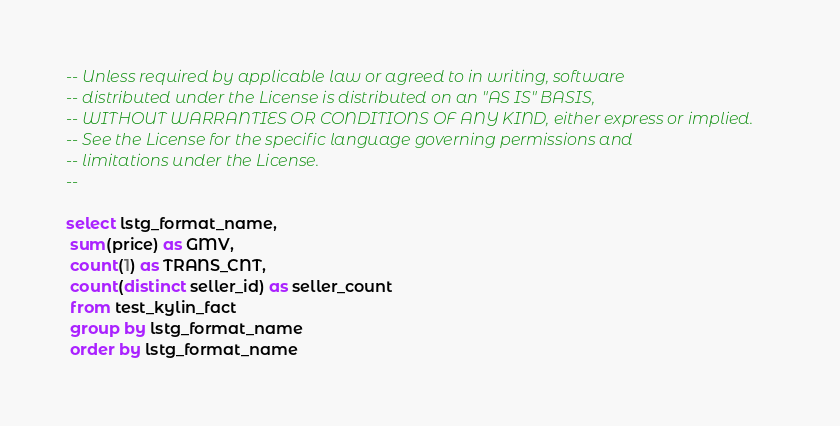<code> <loc_0><loc_0><loc_500><loc_500><_SQL_>-- Unless required by applicable law or agreed to in writing, software
-- distributed under the License is distributed on an "AS IS" BASIS,
-- WITHOUT WARRANTIES OR CONDITIONS OF ANY KIND, either express or implied.
-- See the License for the specific language governing permissions and
-- limitations under the License.
--

select lstg_format_name,
 sum(price) as GMV,
 count(1) as TRANS_CNT,
 count(distinct seller_id) as seller_count
 from test_kylin_fact
 group by lstg_format_name
 order by lstg_format_name
</code> 